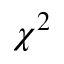<formula> <loc_0><loc_0><loc_500><loc_500>\chi ^ { 2 }</formula> 